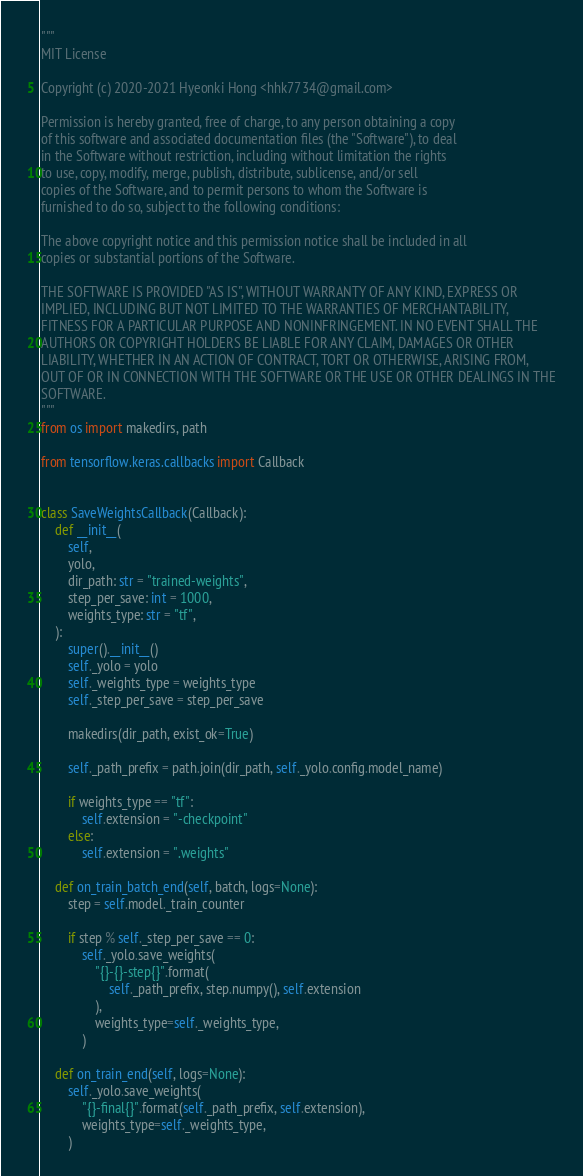Convert code to text. <code><loc_0><loc_0><loc_500><loc_500><_Python_>"""
MIT License

Copyright (c) 2020-2021 Hyeonki Hong <hhk7734@gmail.com>

Permission is hereby granted, free of charge, to any person obtaining a copy
of this software and associated documentation files (the "Software"), to deal
in the Software without restriction, including without limitation the rights
to use, copy, modify, merge, publish, distribute, sublicense, and/or sell
copies of the Software, and to permit persons to whom the Software is
furnished to do so, subject to the following conditions:

The above copyright notice and this permission notice shall be included in all
copies or substantial portions of the Software.

THE SOFTWARE IS PROVIDED "AS IS", WITHOUT WARRANTY OF ANY KIND, EXPRESS OR
IMPLIED, INCLUDING BUT NOT LIMITED TO THE WARRANTIES OF MERCHANTABILITY,
FITNESS FOR A PARTICULAR PURPOSE AND NONINFRINGEMENT. IN NO EVENT SHALL THE
AUTHORS OR COPYRIGHT HOLDERS BE LIABLE FOR ANY CLAIM, DAMAGES OR OTHER
LIABILITY, WHETHER IN AN ACTION OF CONTRACT, TORT OR OTHERWISE, ARISING FROM,
OUT OF OR IN CONNECTION WITH THE SOFTWARE OR THE USE OR OTHER DEALINGS IN THE
SOFTWARE.
"""
from os import makedirs, path

from tensorflow.keras.callbacks import Callback


class SaveWeightsCallback(Callback):
    def __init__(
        self,
        yolo,
        dir_path: str = "trained-weights",
        step_per_save: int = 1000,
        weights_type: str = "tf",
    ):
        super().__init__()
        self._yolo = yolo
        self._weights_type = weights_type
        self._step_per_save = step_per_save

        makedirs(dir_path, exist_ok=True)

        self._path_prefix = path.join(dir_path, self._yolo.config.model_name)

        if weights_type == "tf":
            self.extension = "-checkpoint"
        else:
            self.extension = ".weights"

    def on_train_batch_end(self, batch, logs=None):
        step = self.model._train_counter

        if step % self._step_per_save == 0:
            self._yolo.save_weights(
                "{}-{}-step{}".format(
                    self._path_prefix, step.numpy(), self.extension
                ),
                weights_type=self._weights_type,
            )

    def on_train_end(self, logs=None):
        self._yolo.save_weights(
            "{}-final{}".format(self._path_prefix, self.extension),
            weights_type=self._weights_type,
        )
</code> 